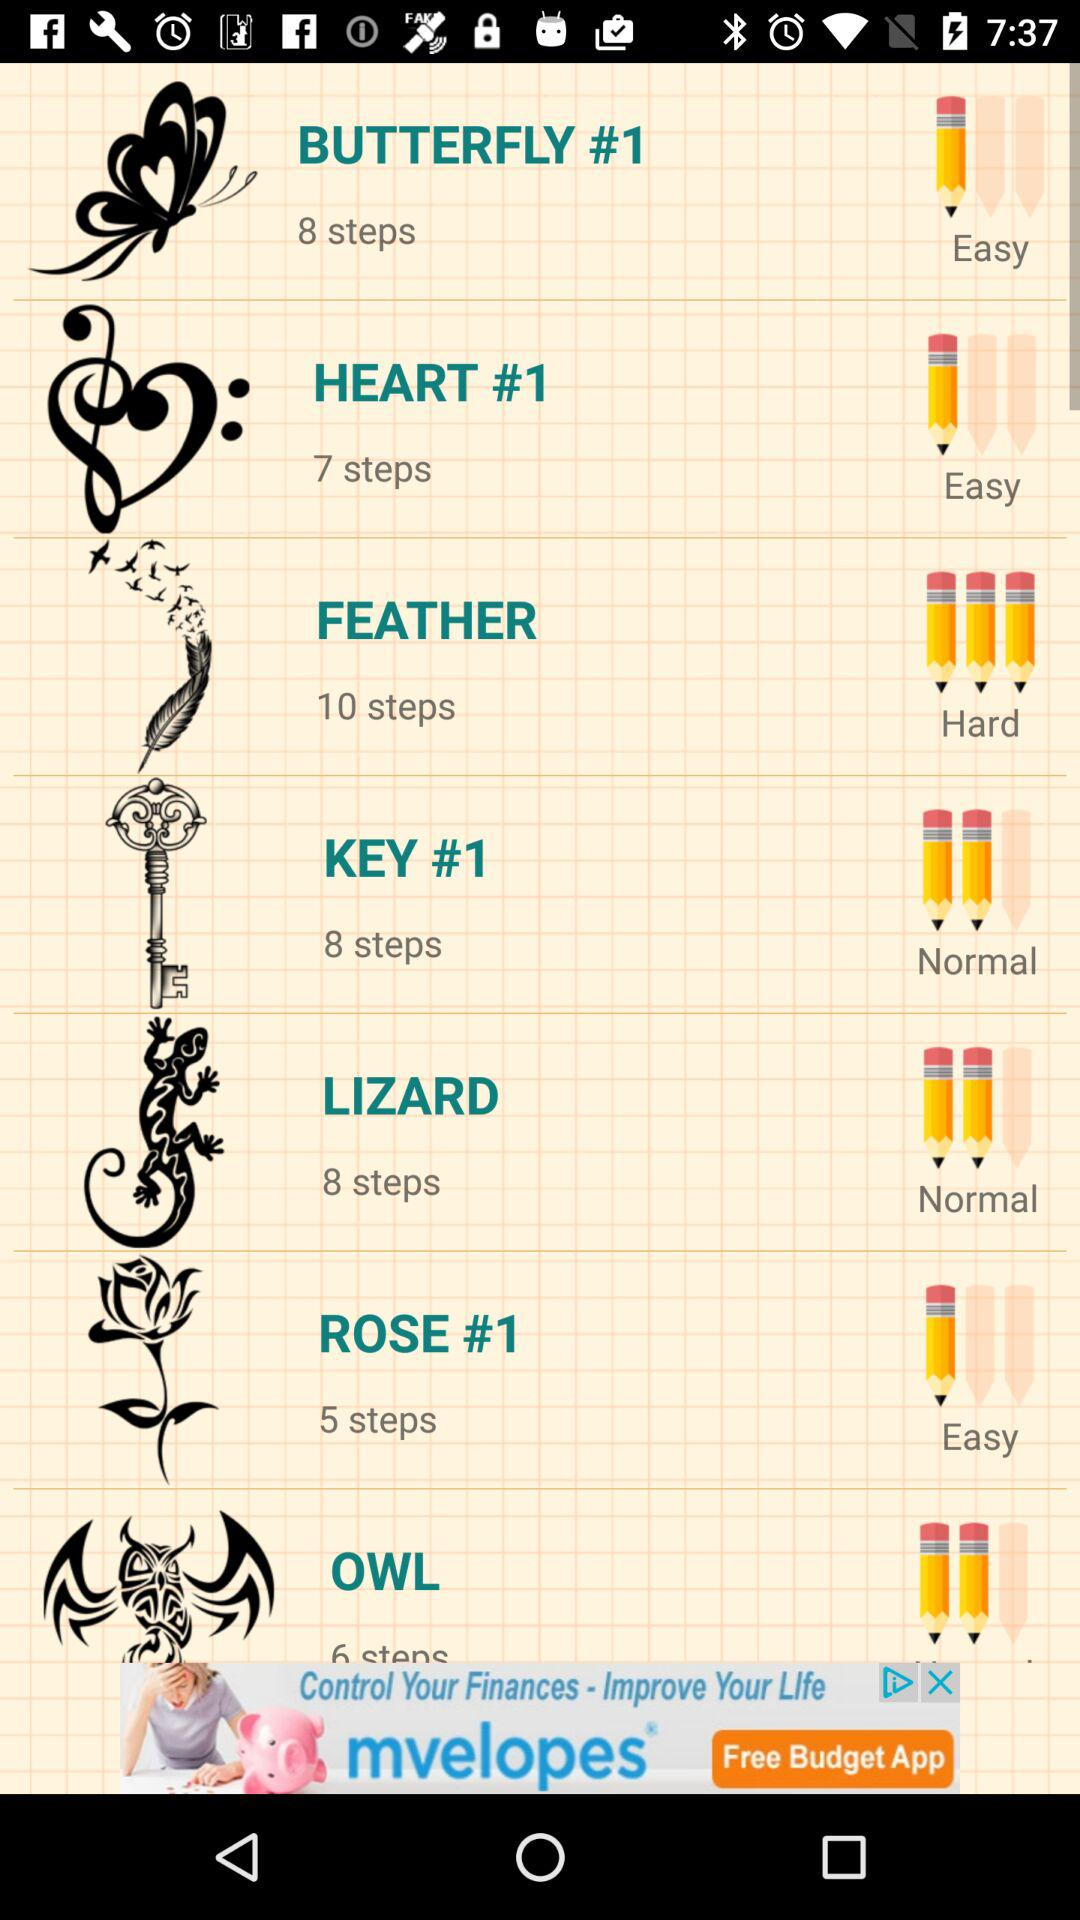What option has 7 steps? The option which has 7 steps is "HEART #1". 